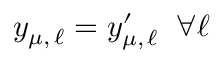Convert formula to latex. <formula><loc_0><loc_0><loc_500><loc_500>y _ { \mu , \, \ell } = y _ { \mu , \, \ell } ^ { \prime } \, \forall \ell</formula> 